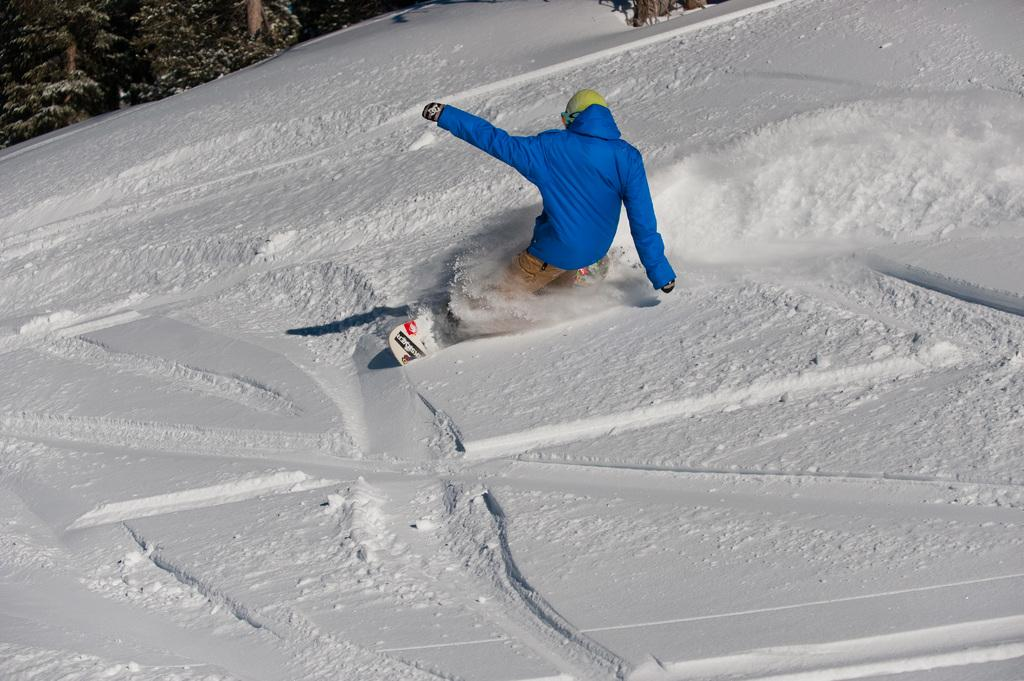Who or what is in the image? There is a person in the image. What is the person wearing? The person is wearing a blue jacket. What is the person doing in the image? The person is standing on a surf. What is the ground made of in the image? There is snow on the floor. What can be seen in the top left corner of the image? There are trees visible in the top left of the image. What is the rate at which the apples are falling from the trees in the image? There are no apples present in the image, so it is not possible to determine the rate at which they might be falling. 